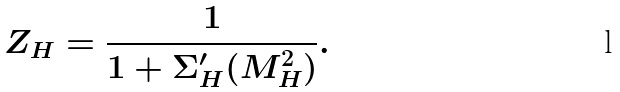<formula> <loc_0><loc_0><loc_500><loc_500>Z _ { H } = \frac { 1 } { 1 + \Sigma _ { H } ^ { \prime } ( M _ { H } ^ { 2 } ) } .</formula> 